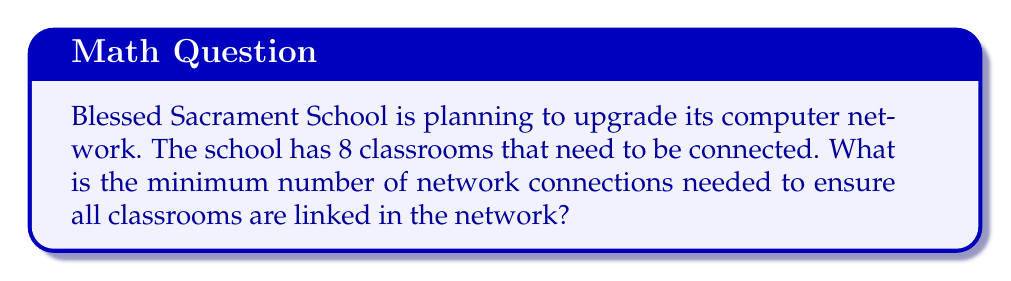Solve this math problem. To solve this problem, we can use concepts from graph theory, specifically the idea of a minimum spanning tree.

1. Each classroom can be represented as a vertex in a graph.
2. The connections between classrooms are the edges of the graph.
3. We need to find the minimum number of edges that connect all vertices (classrooms) without creating any cycles. This is known as a minimum spanning tree.

For a graph with $n$ vertices, the number of edges in a minimum spanning tree is always $n - 1$.

In this case:
* Number of classrooms (vertices) = 8
* Minimum number of connections (edges) = $8 - 1 = 7$

We can visualize this as follows:

[asy]
unitsize(30);
for(int i=0; i<8; ++i) {
  dot((cos(2pi*i/8), sin(2pi*i/8)));
  label("C" + string(i+1), (1.2*cos(2pi*i/8), 1.2*sin(2pi*i/8)));
}
for(int i=0; i<7; ++i) {
  draw((cos(2pi*i/8), sin(2pi*i/8))--(cos(2pi*(i+1)/8), sin(2pi*(i+1)/8)));
}
[/asy]

In this diagram, C1 to C8 represent the 8 classrooms, and the lines between them represent the 7 network connections needed to link all classrooms.
Answer: The minimum number of network connections needed is 7. 